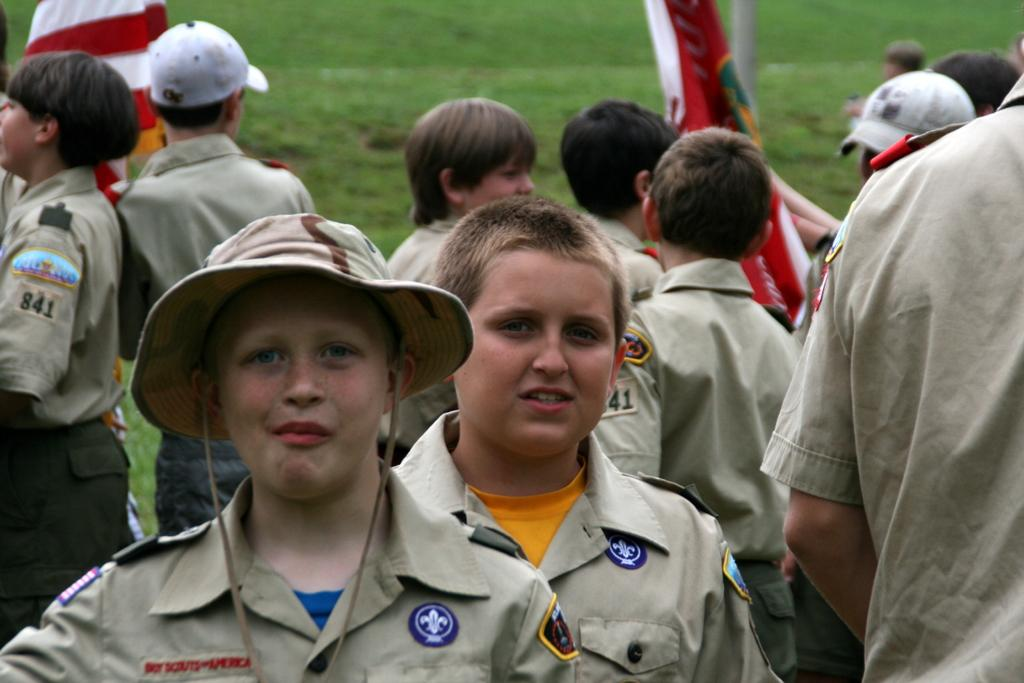What are the kids in the image wearing? The kids in the image are wearing uniforms. Are there any accessories visible on the kids' heads? Yes, some of the kids are wearing caps on their heads. What can be seen in the background of the image? There are flags visible in the background. What type of surface is the kids standing on? There is grass on the ground in the image. Where is the shade provided for the kids in the image? There is no shade visible in the image; the kids are standing in an open area with grass on the ground. How many fans are present in the image? There are no fans visible in the image; the focus is on the kids, their uniforms, caps, and the flags in the background. 